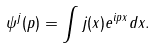<formula> <loc_0><loc_0><loc_500><loc_500>\psi ^ { j } ( { p } ) = \int j ( x ) e ^ { i p x } d { x } .</formula> 